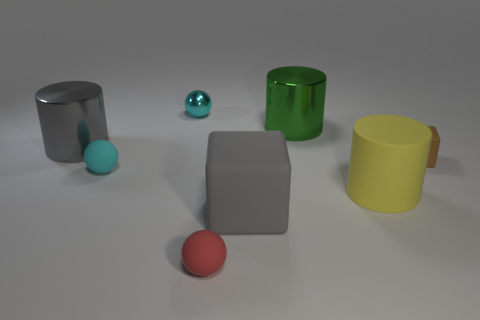Add 2 gray rubber cubes. How many objects exist? 10 Subtract all tiny red spheres. How many spheres are left? 2 Subtract 2 balls. How many balls are left? 1 Subtract all green cylinders. How many cylinders are left? 2 Subtract 1 red balls. How many objects are left? 7 Subtract all blocks. How many objects are left? 6 Subtract all brown blocks. Subtract all red spheres. How many blocks are left? 1 Subtract all purple cylinders. How many brown cubes are left? 1 Subtract all gray objects. Subtract all gray rubber objects. How many objects are left? 5 Add 1 big green cylinders. How many big green cylinders are left? 2 